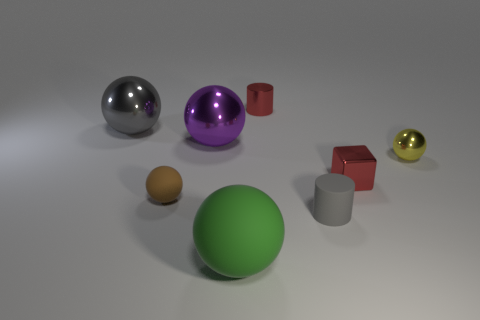Subtract 2 spheres. How many spheres are left? 3 Subtract all green spheres. How many spheres are left? 4 Subtract all brown balls. How many balls are left? 4 Subtract all blue spheres. Subtract all brown cylinders. How many spheres are left? 5 Add 2 large cyan rubber blocks. How many objects exist? 10 Subtract all cylinders. How many objects are left? 6 Subtract 0 blue cylinders. How many objects are left? 8 Subtract all large purple metallic cylinders. Subtract all cubes. How many objects are left? 7 Add 4 large purple spheres. How many large purple spheres are left? 5 Add 6 small red things. How many small red things exist? 8 